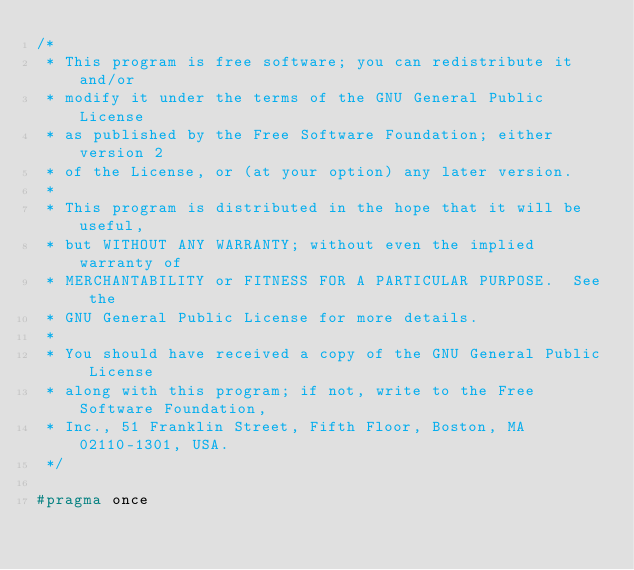Convert code to text. <code><loc_0><loc_0><loc_500><loc_500><_C_>/*
 * This program is free software; you can redistribute it and/or
 * modify it under the terms of the GNU General Public License
 * as published by the Free Software Foundation; either version 2
 * of the License, or (at your option) any later version.
 *
 * This program is distributed in the hope that it will be useful,
 * but WITHOUT ANY WARRANTY; without even the implied warranty of
 * MERCHANTABILITY or FITNESS FOR A PARTICULAR PURPOSE.  See the
 * GNU General Public License for more details.
 *
 * You should have received a copy of the GNU General Public License
 * along with this program; if not, write to the Free Software Foundation,
 * Inc., 51 Franklin Street, Fifth Floor, Boston, MA 02110-1301, USA.
 */

#pragma once
</code> 